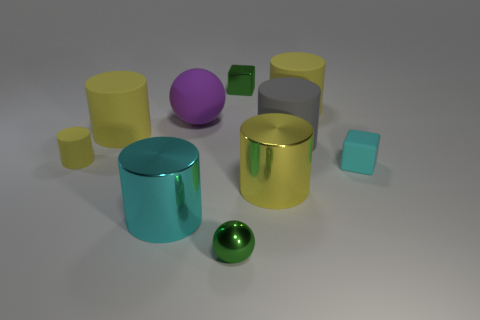How many yellow cylinders must be subtracted to get 1 yellow cylinders? 3 Subtract all cyan cubes. How many yellow cylinders are left? 4 Subtract 3 cylinders. How many cylinders are left? 3 Subtract all gray cylinders. How many cylinders are left? 5 Subtract all large gray cylinders. How many cylinders are left? 5 Subtract all cyan cylinders. Subtract all red blocks. How many cylinders are left? 5 Subtract all cubes. How many objects are left? 8 Subtract all matte cylinders. Subtract all cyan rubber cubes. How many objects are left? 5 Add 6 large spheres. How many large spheres are left? 7 Add 1 tiny brown things. How many tiny brown things exist? 1 